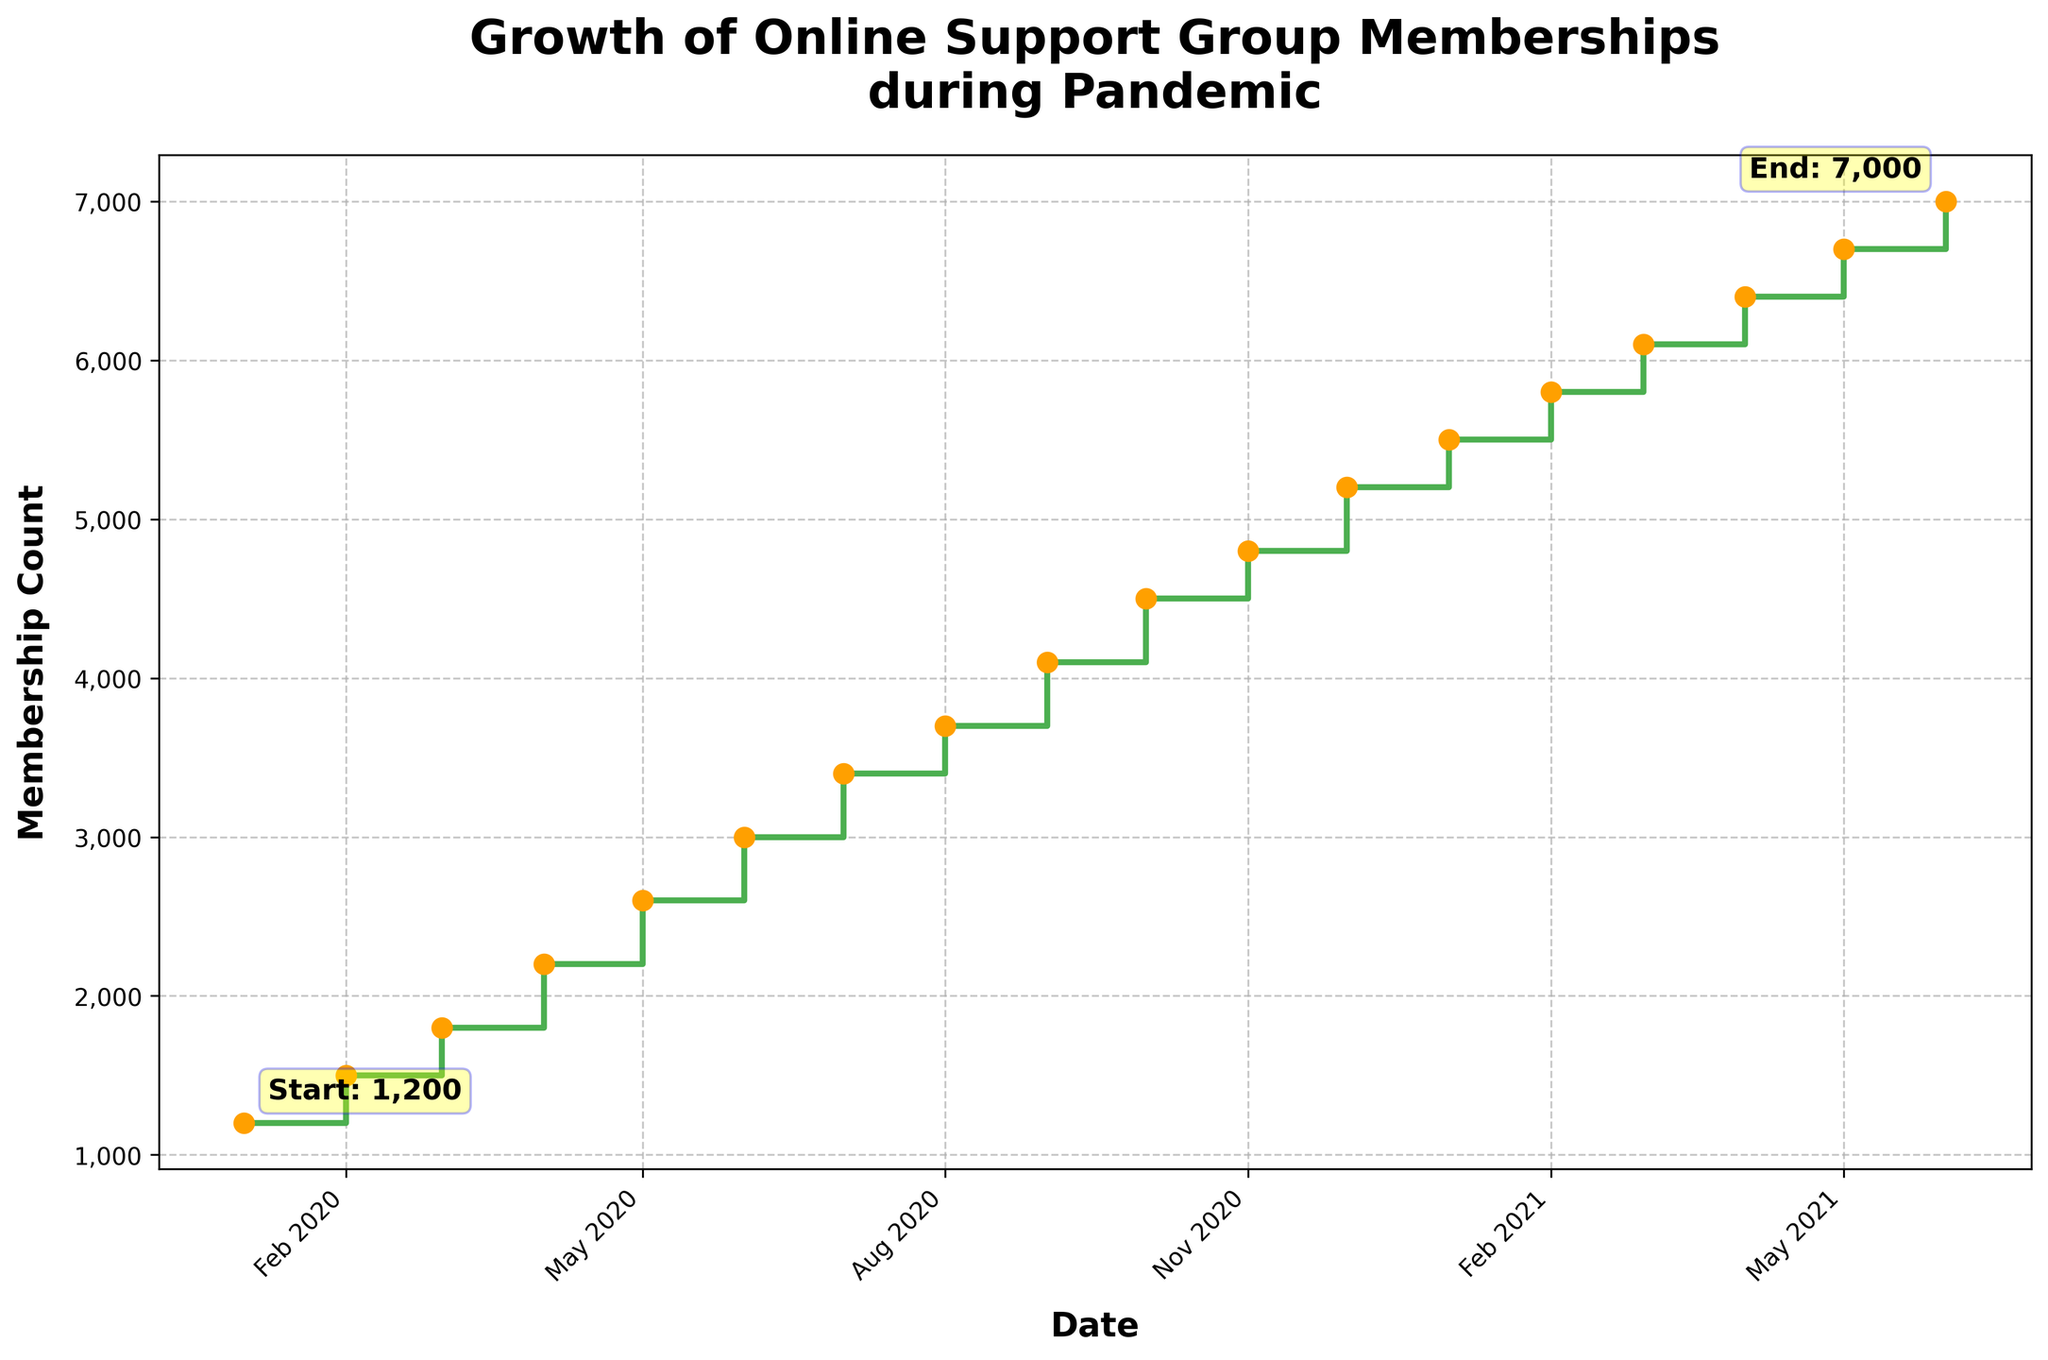What is the title of the figure? The title is located at the top of the figure, displayed prominently in a larger font size for easy identification.
Answer: Growth of Online Support Group Memberships during Pandemic How many data points are plotted in the figure? The figure includes markers at specific intervals which are the data points. By counting these markers, we find there are 18 points.
Answer: 18 What is the membership count at the start of the plotted period? There is a text annotation indicating the membership count at the start, located near the first data point.
Answer: 1,200 What is the highest membership count shown on the plot? The highest membership count is denoted by the text annotation at the end point.
Answer: 7,000 What is the overall trend in the membership count over time? Observing the stepwise increase in the plot and the elevated end compared to the start, the membership count is clearly rising over the period.
Answer: Increasing Between which months did the membership count increase the most? By examining the heights of the steps between each month, the largest gap is between April and May 2020.
Answer: April and May What is the average increase in membership per month from January 2020 to June 2021? To find this: (Ending Membership - Starting Membership) / Number of Months = (7,000 - 1,200) / 17 = 5,800 / 17 ≈ 341.18.
Answer: Approximately 341.18 Which month showed the least growth in membership count? By checking the smallest vertical step between data points, the minimal increase occurs between December 2020 and January 2021.
Answer: December 2020 to January 2021 Did the membership count ever decrease at any point during the plotted period? The step plot only shows upward steps indicating continuous growth without any decreases.
Answer: No Is the growth rate steady throughout the plotted period? By observing the varying heights between steps, the growth rate is not steady; some months show larger changes than others.
Answer: No 